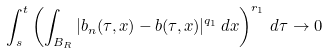<formula> <loc_0><loc_0><loc_500><loc_500>\int _ { s } ^ { t } \left ( \int _ { B _ { R } } | b _ { n } ( \tau , x ) - b ( \tau , x ) | ^ { q _ { 1 } } \, d x \right ) ^ { r _ { 1 } } \, d \tau \to 0</formula> 